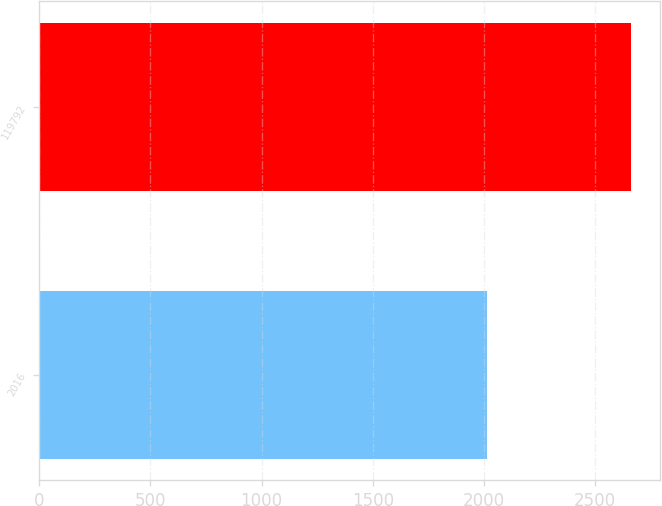<chart> <loc_0><loc_0><loc_500><loc_500><bar_chart><fcel>2016<fcel>119792<nl><fcel>2015<fcel>2660.7<nl></chart> 